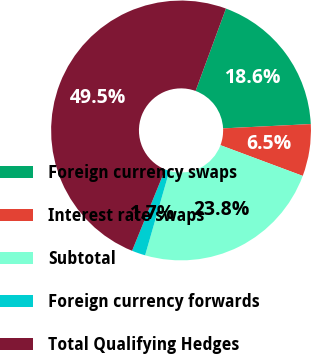Convert chart to OTSL. <chart><loc_0><loc_0><loc_500><loc_500><pie_chart><fcel>Foreign currency swaps<fcel>Interest rate swaps<fcel>Subtotal<fcel>Foreign currency forwards<fcel>Total Qualifying Hedges<nl><fcel>18.6%<fcel>6.47%<fcel>23.77%<fcel>1.69%<fcel>49.47%<nl></chart> 